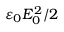<formula> <loc_0><loc_0><loc_500><loc_500>\varepsilon _ { 0 } E _ { 0 } ^ { 2 } / 2</formula> 